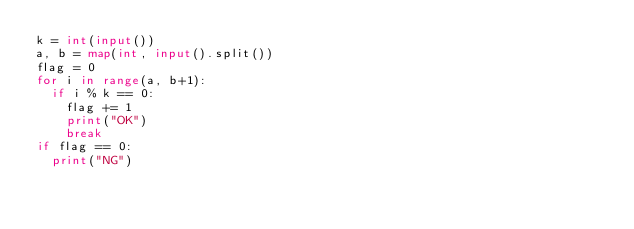<code> <loc_0><loc_0><loc_500><loc_500><_Python_>k = int(input())
a, b = map(int, input().split())
flag = 0
for i in range(a, b+1):
  if i % k == 0:
    flag += 1
    print("OK")
    break
if flag == 0:
  print("NG")
    </code> 